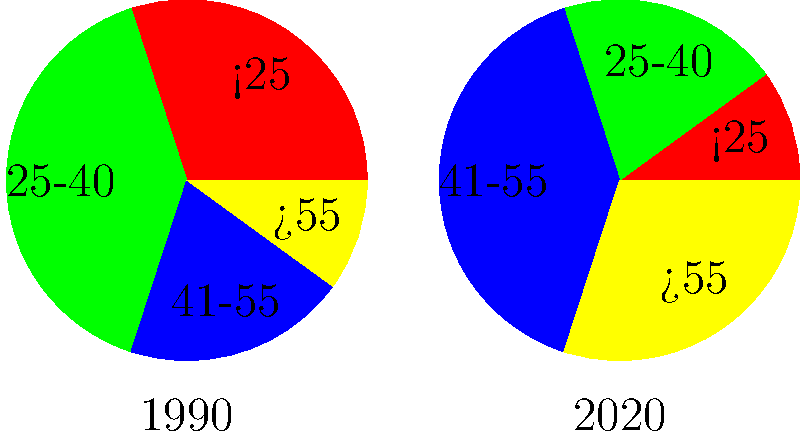Analyzing the age demographics of rock/metal fans in 1990 and 2020, what is the most significant change observed in the pie charts? To determine the most significant change in age demographics of rock/metal fans between 1990 and 2020, we need to compare the percentages for each age group:

1. Age group <25:
   1990: 30%, 2020: 10%
   Change: -20%

2. Age group 25-40:
   1990: 40%, 2020: 20%
   Change: -20%

3. Age group 41-55:
   1990: 20%, 2020: 40%
   Change: +20%

4. Age group >55:
   1990: 10%, 2020: 30%
   Change: +20%

The most significant changes are:
a) The decrease in the percentage of fans under 40 years old
b) The increase in the percentage of fans over 40 years old

Both changes are equally significant in terms of magnitude (20% each). However, the most notable change is the shift from a predominantly younger fanbase to an older one. This is particularly evident in the reversal of the largest age group from 25-40 in 1990 to 41-55 in 2020.

This change aligns with the persona of "a long-time fan saddened by the decline in interest for rock/metal genres," as it shows that the fanbase is aging and not being replenished by younger fans at the same rate as in the past.
Answer: Aging fanbase 